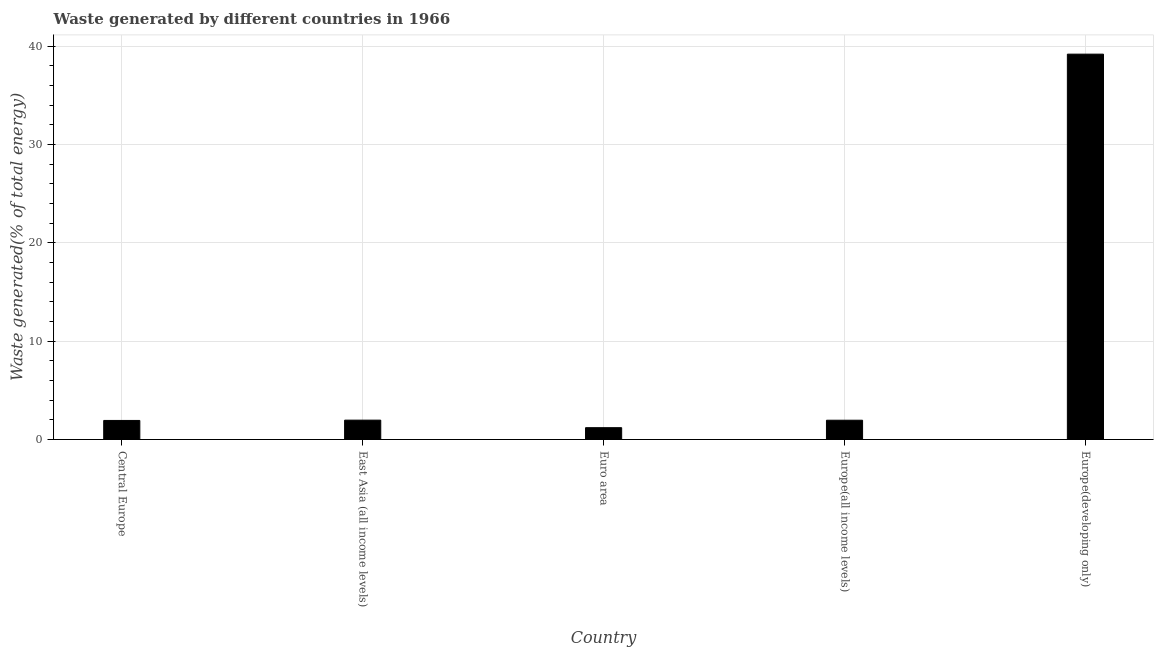What is the title of the graph?
Your answer should be compact. Waste generated by different countries in 1966. What is the label or title of the X-axis?
Offer a very short reply. Country. What is the label or title of the Y-axis?
Make the answer very short. Waste generated(% of total energy). What is the amount of waste generated in Euro area?
Make the answer very short. 1.2. Across all countries, what is the maximum amount of waste generated?
Your response must be concise. 39.18. Across all countries, what is the minimum amount of waste generated?
Give a very brief answer. 1.2. In which country was the amount of waste generated maximum?
Your answer should be compact. Europe(developing only). In which country was the amount of waste generated minimum?
Offer a very short reply. Euro area. What is the sum of the amount of waste generated?
Provide a short and direct response. 46.25. What is the difference between the amount of waste generated in Euro area and Europe(all income levels)?
Ensure brevity in your answer.  -0.76. What is the average amount of waste generated per country?
Make the answer very short. 9.25. What is the median amount of waste generated?
Provide a short and direct response. 1.96. What is the ratio of the amount of waste generated in East Asia (all income levels) to that in Europe(developing only)?
Your answer should be very brief. 0.05. Is the amount of waste generated in Europe(all income levels) less than that in Europe(developing only)?
Ensure brevity in your answer.  Yes. What is the difference between the highest and the second highest amount of waste generated?
Provide a short and direct response. 37.21. Is the sum of the amount of waste generated in Euro area and Europe(all income levels) greater than the maximum amount of waste generated across all countries?
Your response must be concise. No. What is the difference between the highest and the lowest amount of waste generated?
Ensure brevity in your answer.  37.97. In how many countries, is the amount of waste generated greater than the average amount of waste generated taken over all countries?
Offer a very short reply. 1. How many bars are there?
Provide a short and direct response. 5. Are all the bars in the graph horizontal?
Make the answer very short. No. How many countries are there in the graph?
Offer a terse response. 5. What is the difference between two consecutive major ticks on the Y-axis?
Provide a short and direct response. 10. What is the Waste generated(% of total energy) of Central Europe?
Your response must be concise. 1.94. What is the Waste generated(% of total energy) in East Asia (all income levels)?
Give a very brief answer. 1.97. What is the Waste generated(% of total energy) in Euro area?
Your answer should be very brief. 1.2. What is the Waste generated(% of total energy) of Europe(all income levels)?
Provide a succinct answer. 1.96. What is the Waste generated(% of total energy) in Europe(developing only)?
Ensure brevity in your answer.  39.18. What is the difference between the Waste generated(% of total energy) in Central Europe and East Asia (all income levels)?
Your response must be concise. -0.03. What is the difference between the Waste generated(% of total energy) in Central Europe and Euro area?
Make the answer very short. 0.74. What is the difference between the Waste generated(% of total energy) in Central Europe and Europe(all income levels)?
Give a very brief answer. -0.02. What is the difference between the Waste generated(% of total energy) in Central Europe and Europe(developing only)?
Your answer should be compact. -37.24. What is the difference between the Waste generated(% of total energy) in East Asia (all income levels) and Euro area?
Your answer should be compact. 0.77. What is the difference between the Waste generated(% of total energy) in East Asia (all income levels) and Europe(all income levels)?
Your response must be concise. 0.01. What is the difference between the Waste generated(% of total energy) in East Asia (all income levels) and Europe(developing only)?
Ensure brevity in your answer.  -37.21. What is the difference between the Waste generated(% of total energy) in Euro area and Europe(all income levels)?
Offer a very short reply. -0.76. What is the difference between the Waste generated(% of total energy) in Euro area and Europe(developing only)?
Offer a very short reply. -37.97. What is the difference between the Waste generated(% of total energy) in Europe(all income levels) and Europe(developing only)?
Ensure brevity in your answer.  -37.22. What is the ratio of the Waste generated(% of total energy) in Central Europe to that in Euro area?
Offer a very short reply. 1.61. What is the ratio of the Waste generated(% of total energy) in Central Europe to that in Europe(all income levels)?
Ensure brevity in your answer.  0.99. What is the ratio of the Waste generated(% of total energy) in East Asia (all income levels) to that in Euro area?
Ensure brevity in your answer.  1.64. What is the ratio of the Waste generated(% of total energy) in East Asia (all income levels) to that in Europe(developing only)?
Your answer should be compact. 0.05. What is the ratio of the Waste generated(% of total energy) in Euro area to that in Europe(all income levels)?
Your answer should be very brief. 0.61. What is the ratio of the Waste generated(% of total energy) in Euro area to that in Europe(developing only)?
Offer a very short reply. 0.03. What is the ratio of the Waste generated(% of total energy) in Europe(all income levels) to that in Europe(developing only)?
Provide a short and direct response. 0.05. 